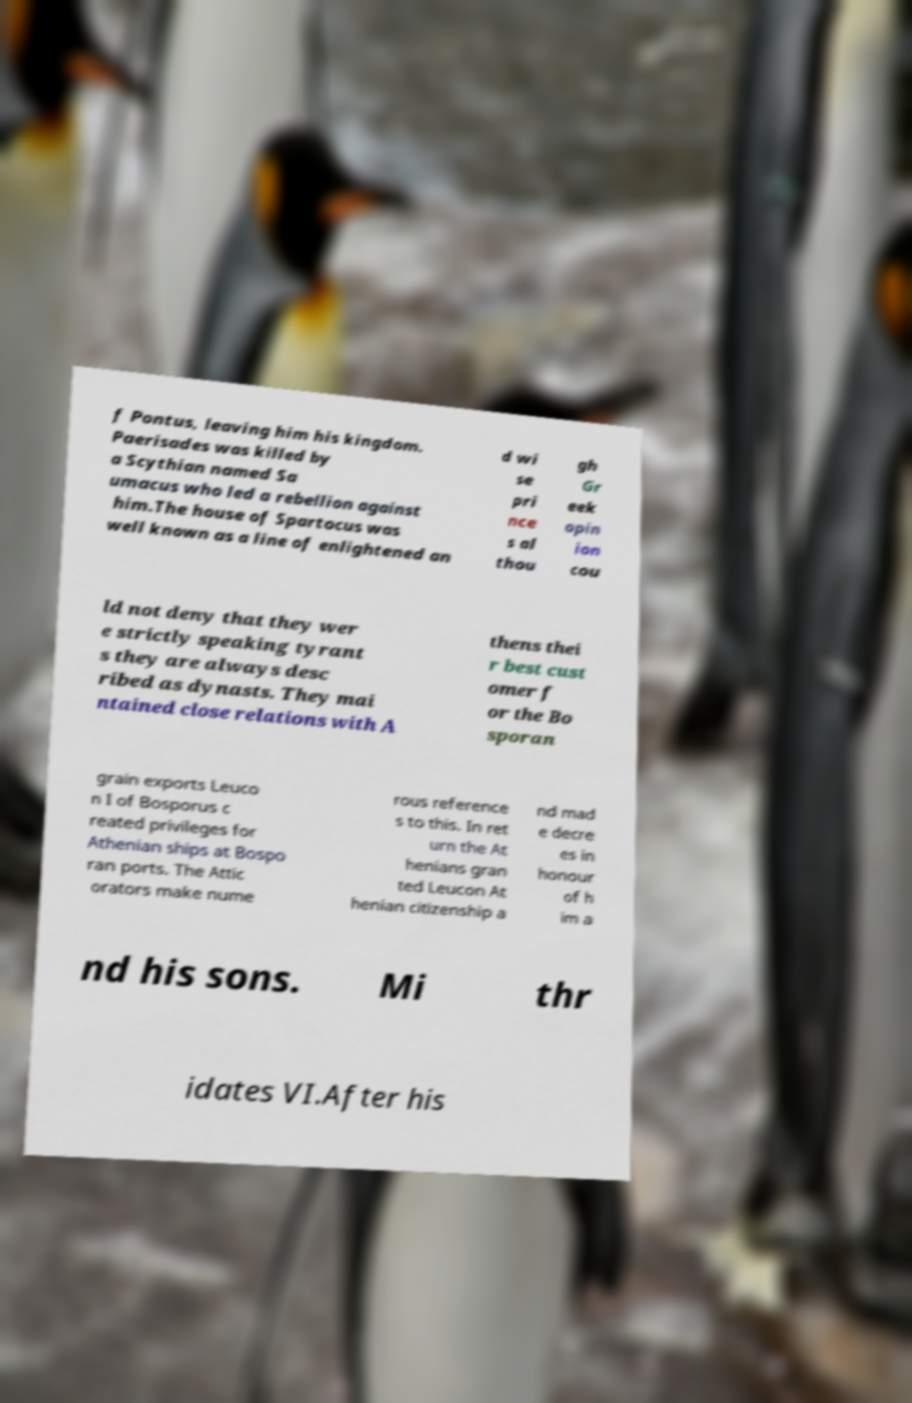Please read and relay the text visible in this image. What does it say? f Pontus, leaving him his kingdom. Paerisades was killed by a Scythian named Sa umacus who led a rebellion against him.The house of Spartocus was well known as a line of enlightened an d wi se pri nce s al thou gh Gr eek opin ion cou ld not deny that they wer e strictly speaking tyrant s they are always desc ribed as dynasts. They mai ntained close relations with A thens thei r best cust omer f or the Bo sporan grain exports Leuco n I of Bosporus c reated privileges for Athenian ships at Bospo ran ports. The Attic orators make nume rous reference s to this. In ret urn the At henians gran ted Leucon At henian citizenship a nd mad e decre es in honour of h im a nd his sons. Mi thr idates VI.After his 